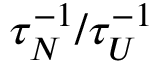<formula> <loc_0><loc_0><loc_500><loc_500>\tau _ { N } ^ { - 1 } / \tau _ { U } ^ { - 1 }</formula> 